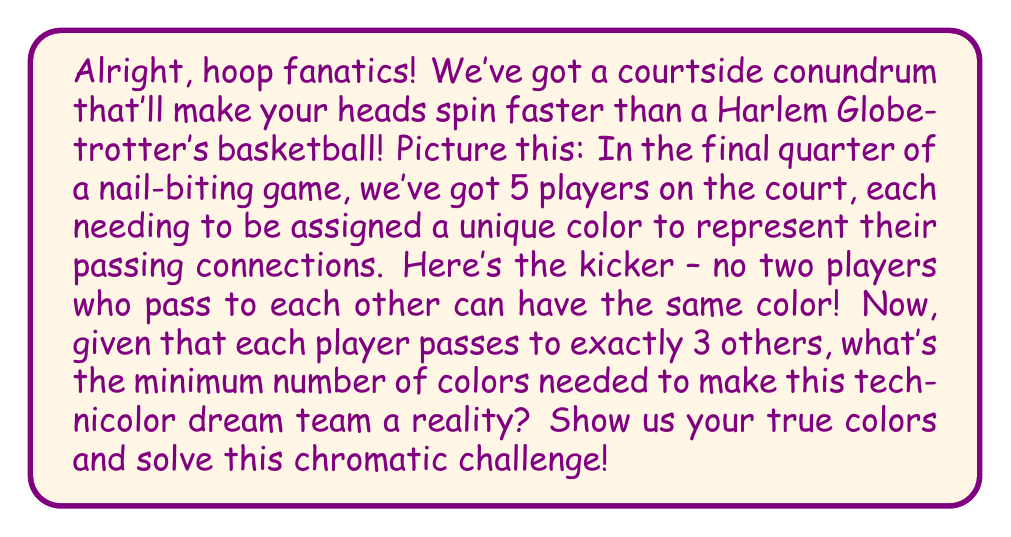Provide a solution to this math problem. Let's break this down step by step, sports fans!

1) First, we need to recognize that this scenario can be represented as a graph coloring problem. Each player is a vertex, and each passing connection is an edge.

2) We're told that each player passes to exactly 3 others. In graph theory terms, this means we have a 3-regular graph with 5 vertices.

3) Now, here's a slam dunk of a theorem: The chromatic number of a graph is always less than or equal to the maximum degree of the graph plus one. In mathematical notation:

   $$\chi(G) \leq \Delta(G) + 1$$

   where $\chi(G)$ is the chromatic number and $\Delta(G)$ is the maximum degree.

4) In our case, $\Delta(G) = 3$, so we know that $\chi(G) \leq 4$.

5) But can we do better? Let's investigate! In a 5-vertex graph where each vertex has degree 3, we have a total of $\frac{5 \times 3}{2} = 7.5$ edges. Since we can't have half an edge, this tells us our graph must have exactly 7 edges.

6) The only way to arrange 7 edges among 5 vertices, each with degree 3, is in a configuration known as the 5-cycle with chords. It looks like this:

   [asy]
   unitsize(2cm);
   pair[] A = {dir(90), dir(18), dir(-54), dir(-126), dir(162)};
   for(int i=0; i<5; ++i) {
     dot(A[i]);
     draw(A[i]--A[(i+1)%5]);
     draw(A[i]--A[(i+2)%5]);
   }
   [/asy]

7) This graph is famous in graph theory - it's the smallest graph with chromatic number 4!

8) Therefore, we can't color this graph with fewer than 4 colors.

So, there you have it! The minimum number of colors needed is indeed 4, and that's no layup - it's a full-court mathematical proof!
Answer: 4 colors 